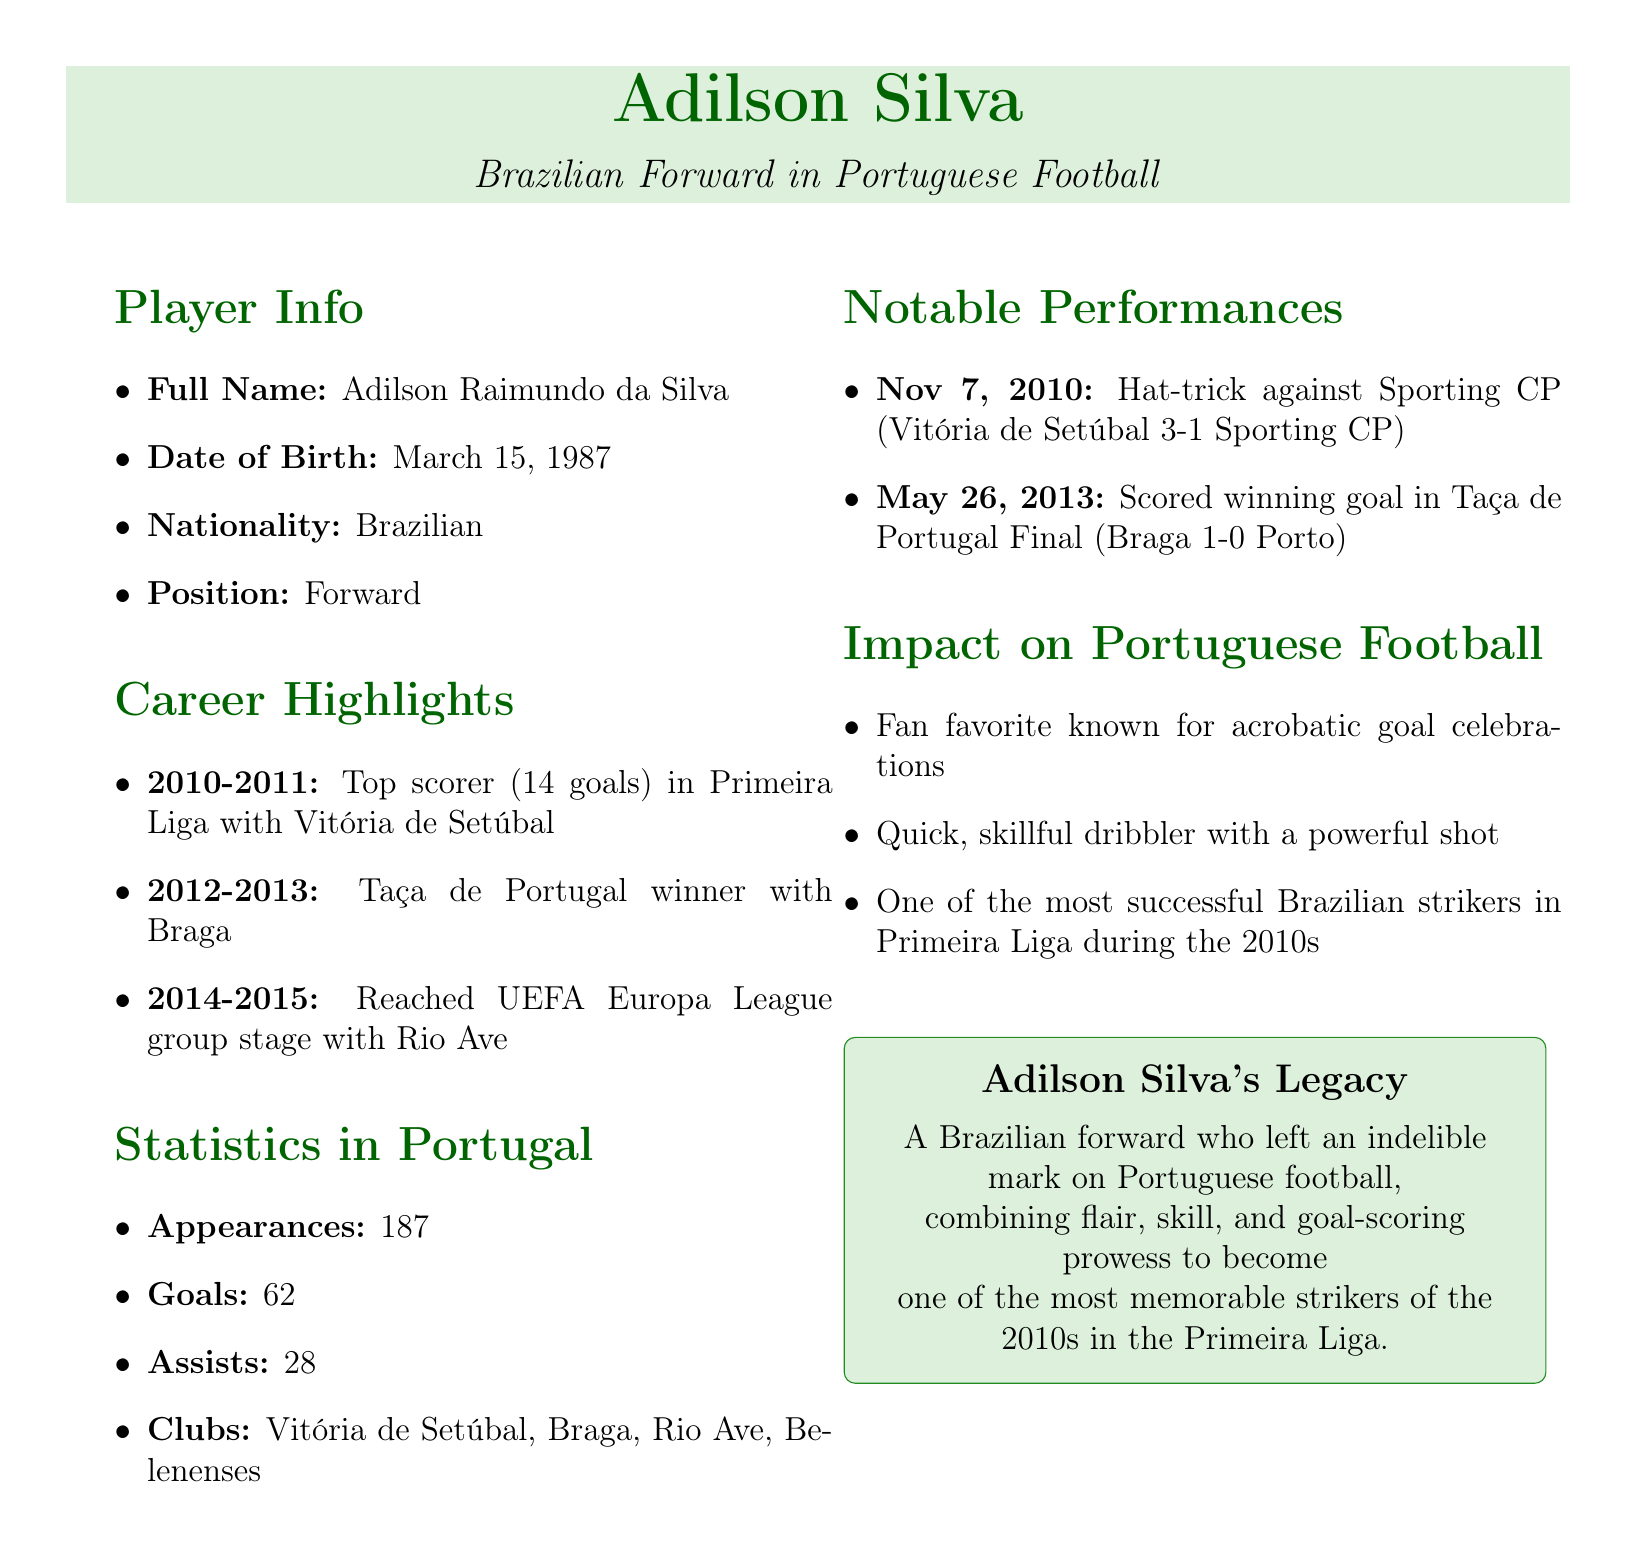What is Adilson Silva's date of birth? The document states that Adilson Silva was born on March 15, 1987.
Answer: March 15, 1987 How many goals did Adilson score in the 2010-2011 season? According to the career highlights, Adilson was the top scorer with 14 goals during the 2010-2011 season.
Answer: 14 goals Which club did Adilson play for when he won the Taça de Portugal? The document mentions that Adilson won the Taça de Portugal while playing for Braga in the 2012-2013 season.
Answer: Braga What is the total number of assists provided by Adilson in Portugal? The statistics indicate that Adilson provided a total of 28 assists during his time in Portugal.
Answer: 28 What notable performance took place on May 26, 2013? The document highlights that Adilson scored the winning goal in the Taça de Portugal Final on this date.
Answer: Scored the winning goal Which style of play is Adilson Silva known for? The document describes his playing style as being a quick, skillful dribbler with a powerful shot.
Answer: Quick, skillful dribbler with a powerful shot How many clubs did Adilson play for in Portugal? The statistics section lists four clubs where Adilson played, indicating the number of clubs as 4.
Answer: 4 What is Adilson's impact on Portuguese football? The document states that he is one of the most successful Brazilian strikers in Primeira Liga during the 2010s.
Answer: One of the most successful Brazilian strikers in Primeira Liga during the 2010s 